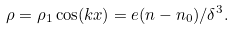<formula> <loc_0><loc_0><loc_500><loc_500>\rho = \rho _ { 1 } \cos ( k x ) = e ( n - n _ { 0 } ) / \delta ^ { 3 } .</formula> 